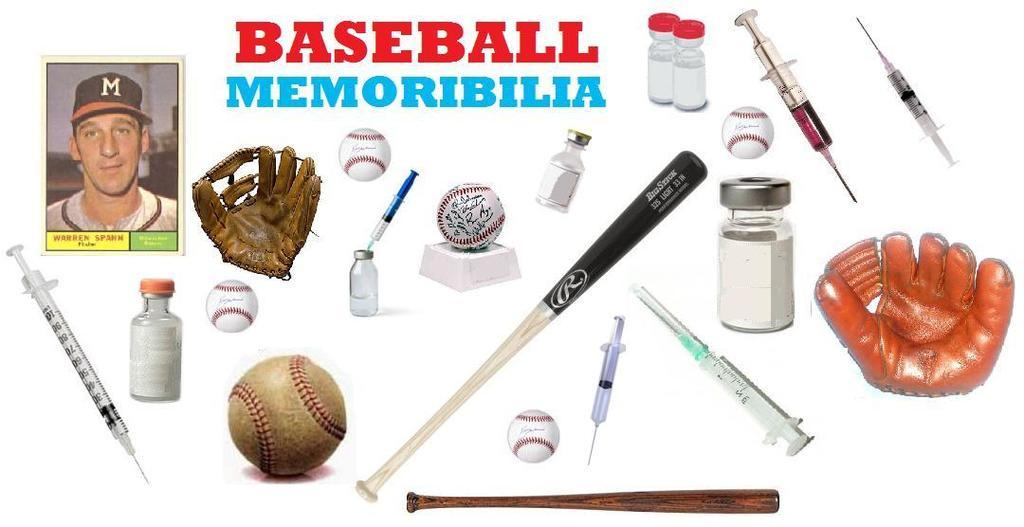What is the main subject of the image? There is a photograph in the image. What items can be seen in the photograph? Gloves, injections, bottles, balls, and baseball bats are visible in the photograph. What is the color of the background in the image? The background of the image is white. What is written at the top of the image? There is text at the top of the image. Can you tell me how many celery sticks are on the table in the image? There is no table or celery sticks present in the image. What type of harmony is being displayed by the donkey in the image? There is no donkey present in the image, so it is not possible to determine any type of harmony being displayed. 